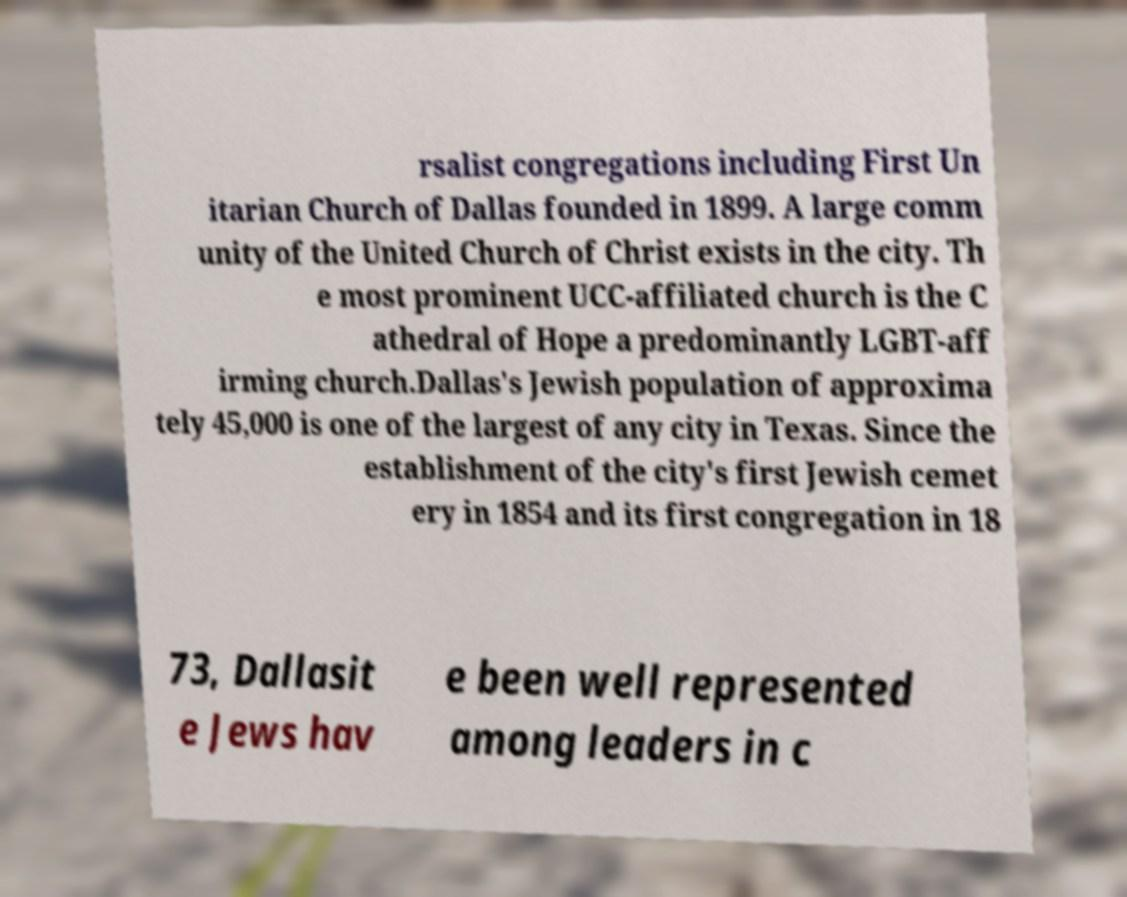Please read and relay the text visible in this image. What does it say? rsalist congregations including First Un itarian Church of Dallas founded in 1899. A large comm unity of the United Church of Christ exists in the city. Th e most prominent UCC-affiliated church is the C athedral of Hope a predominantly LGBT-aff irming church.Dallas's Jewish population of approxima tely 45,000 is one of the largest of any city in Texas. Since the establishment of the city's first Jewish cemet ery in 1854 and its first congregation in 18 73, Dallasit e Jews hav e been well represented among leaders in c 